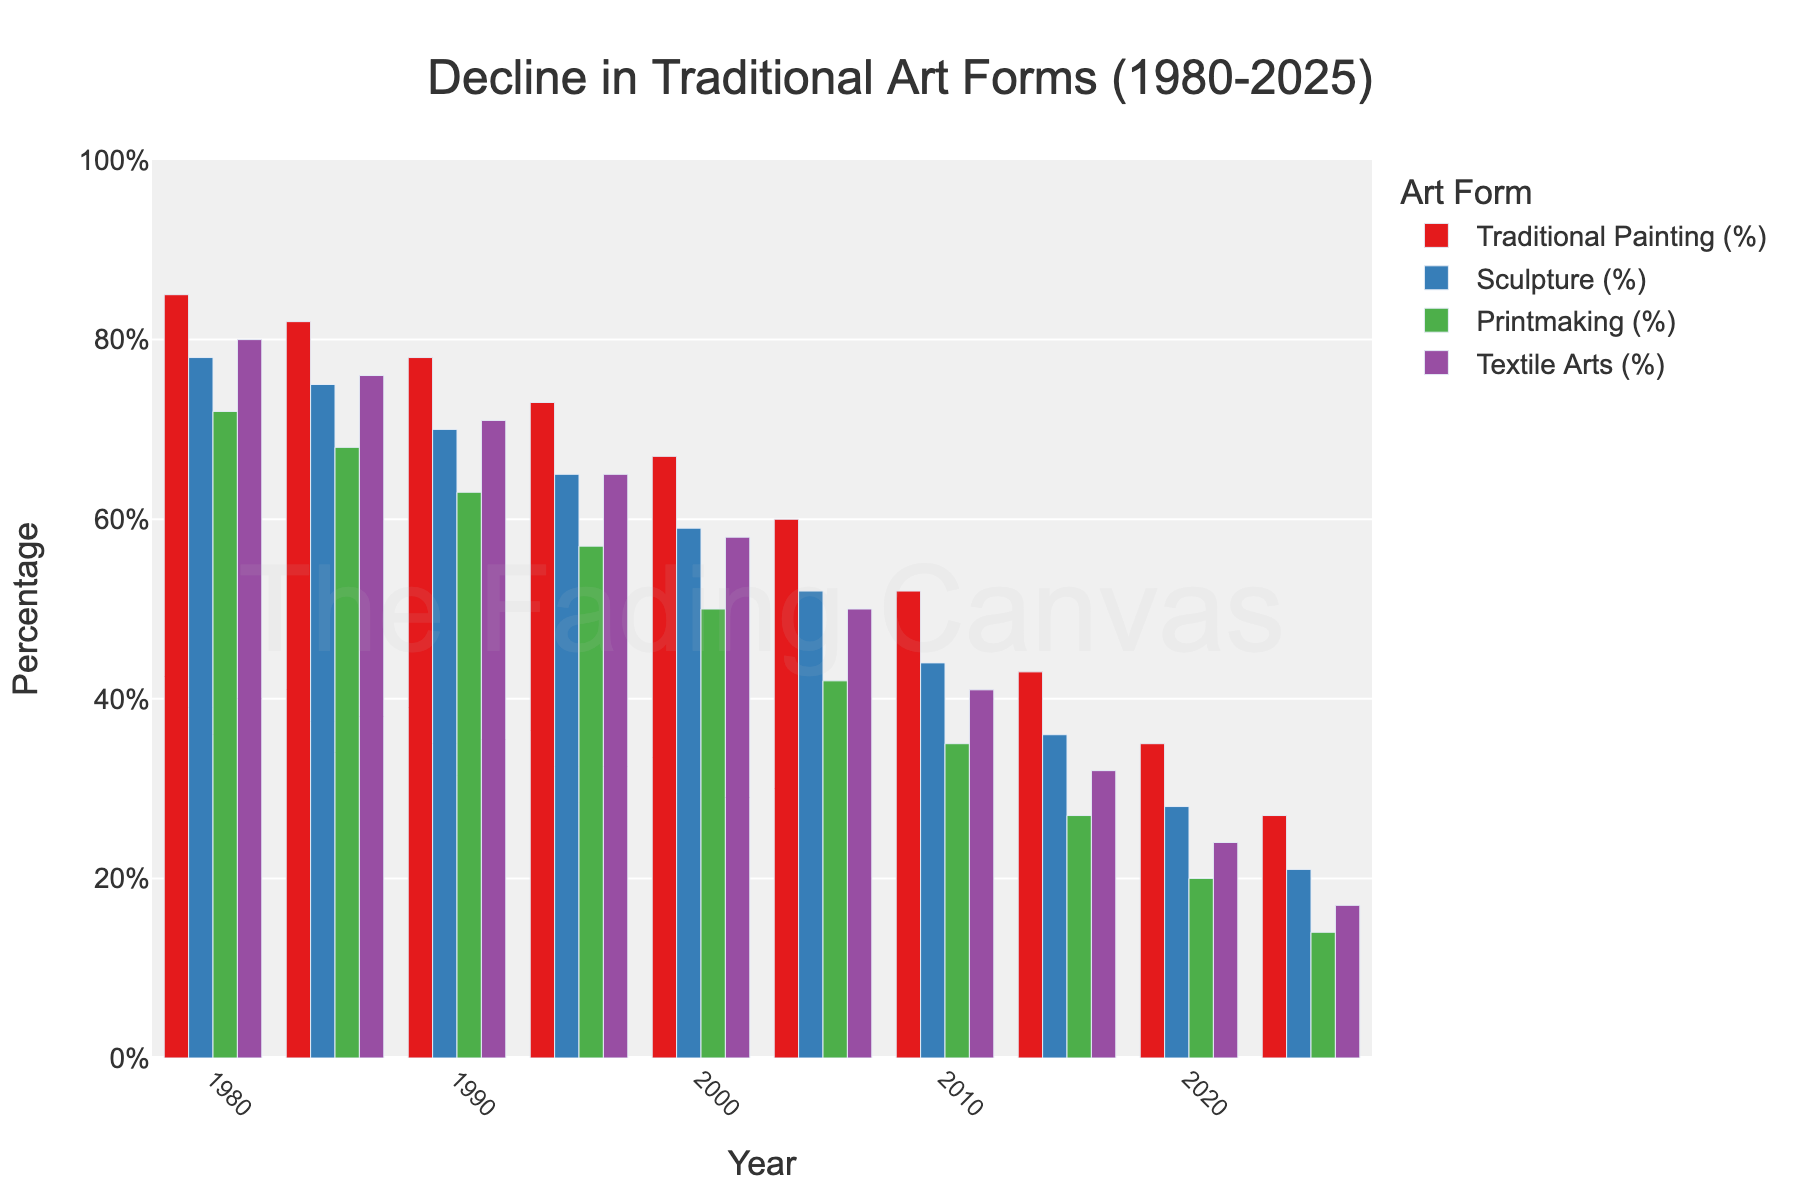What year saw the greatest percentage decline in Traditional Painting compared to the previous period? To find this, look at the percentage differences between consecutive years for Traditional Painting. The table shows the values and the greatest decline is between 2015 and 2020 from 43% to 35%, a decline of 8%.
Answer: 2015-2020 Which traditional art form saw the smallest decrease in percentage from 1980 to 2025? Check the initial (1980) and final (2025) percentages for each art form and calculate the difference. Textile Arts decreased from 80% to 17%, a difference of 63%. This is smaller than the other art forms.
Answer: Textile Arts In what year did Sculpture first fall below 30%? Check the percentages for Sculpture by year. It falls below 30% in 2020.
Answer: 2020 By how much did Printmaking's percentage change from 1980 to 2000? To find this, subtract the 2000 percentage (50%) from the 1980 percentage (72%). So, 72% - 50% = 22%.
Answer: 22% What is the overall trend for Textile Arts from 1980 to 2025? Look at the percentage values across the years for Textile Arts; the trend consistently shows a decline from 80% in 1980 to 17% in 2025.
Answer: Declining How does the percentage of Traditional Painting in 1985 compare to that in 2025? Compare the values directly: Traditional Painting is 82% in 1985 and 27% in 2025. 82% - 27% = 55%.
Answer: 55% Which art form had the highest percentage in 1990? Compare the 1990 percentages: Traditional Painting (78%), Sculpture (70%), Printmaking (63%), Textile Arts (71%). Traditional Painting had the highest percentage.
Answer: Traditional Painting What is the combined percentage for all the art forms in 2005? Add the percentages for 2005: 60% (Traditional Painting) + 52% (Sculpture) + 42% (Printmaking) + 50% (Textile Arts) = 204%.
Answer: 204% Between 2000 and 2010, which art form experienced the greatest percentage decline? Calculate the percentage declines for each art form between 2000 and 2010. Traditional Painting: 67% to 52% (15%), Sculpture: 59% to 44% (15%), Printmaking: 50% to 35% (15%), Textile Arts: 58% to 41% (17%). Textile Arts experienced the greatest decline.
Answer: Textile Arts What is the relationship between Sculpture and Printmaking percentages in 2025? Compare the 2025 values: Sculpture is 21%, Printmaking is 14%. Sculpture's percentage is higher than Printmaking's by 7%.
Answer: Sculpture > Printmaking 